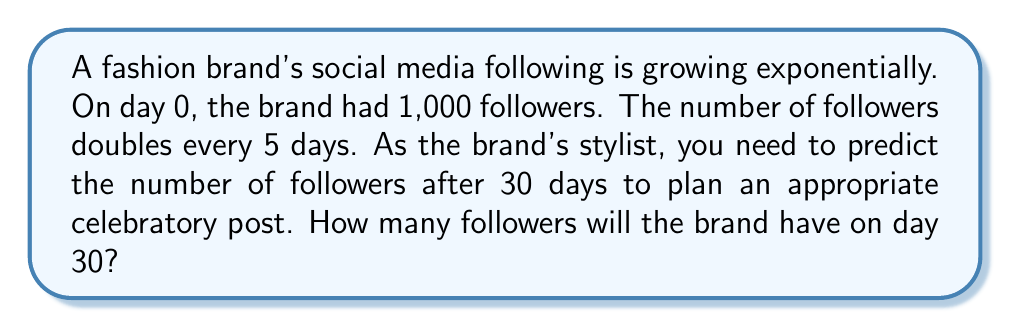Solve this math problem. Let's approach this step-by-step:

1) We can model this situation with an exponential function:
   $$ f(t) = 1000 \cdot 2^{\frac{t}{5}} $$
   Where $f(t)$ is the number of followers after $t$ days.

2) We need to find $f(30)$:
   $$ f(30) = 1000 \cdot 2^{\frac{30}{5}} $$

3) Simplify the exponent:
   $$ f(30) = 1000 \cdot 2^6 $$

4) Calculate $2^6$:
   $$ f(30) = 1000 \cdot 64 $$

5) Multiply:
   $$ f(30) = 64,000 $$

Therefore, after 30 days, the brand will have 64,000 followers.
Answer: 64,000 followers 